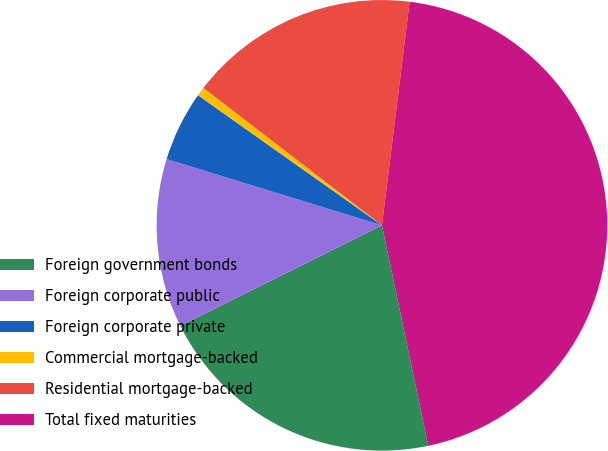Convert chart. <chart><loc_0><loc_0><loc_500><loc_500><pie_chart><fcel>Foreign government bonds<fcel>Foreign corporate public<fcel>Foreign corporate private<fcel>Commercial mortgage-backed<fcel>Residential mortgage-backed<fcel>Total fixed maturities<nl><fcel>20.93%<fcel>12.11%<fcel>5.05%<fcel>0.64%<fcel>16.52%<fcel>44.74%<nl></chart> 